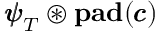<formula> <loc_0><loc_0><loc_500><loc_500>{ \pm b { \psi } } _ { T } \circledast p a d ( { \pm b { c } } )</formula> 